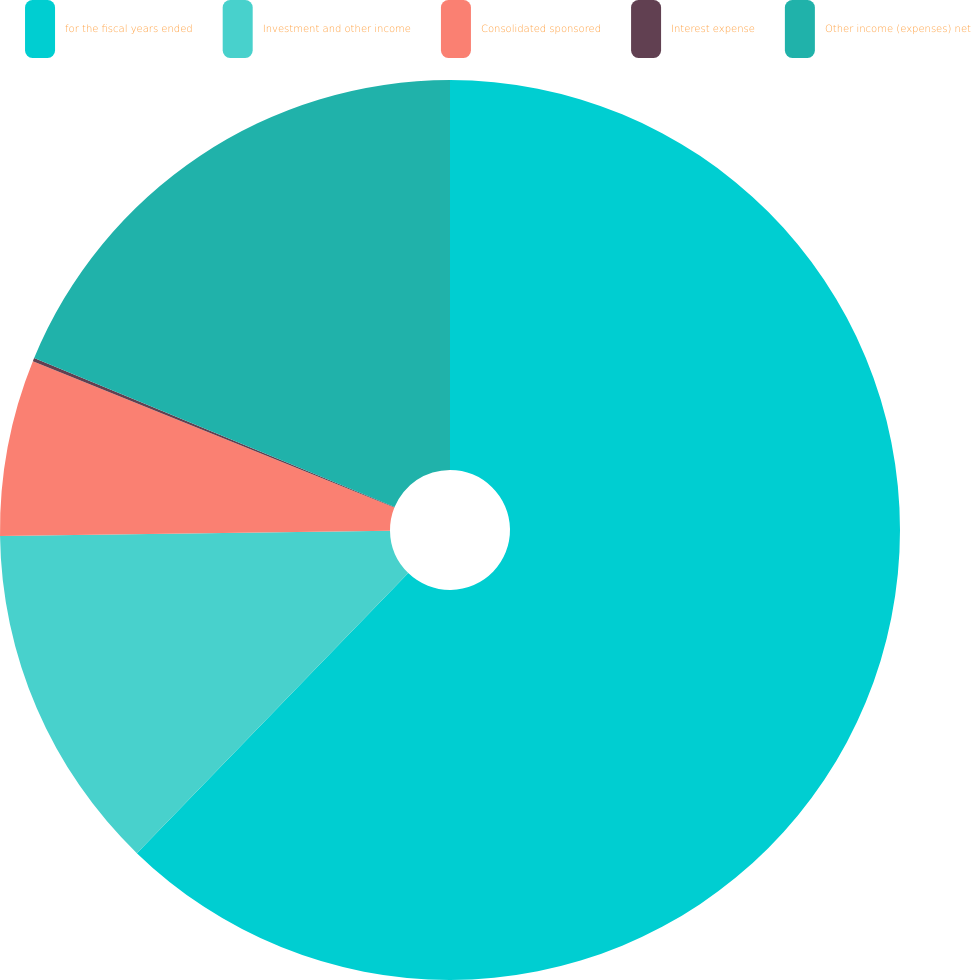<chart> <loc_0><loc_0><loc_500><loc_500><pie_chart><fcel>for the fiscal years ended<fcel>Investment and other income<fcel>Consolidated sponsored<fcel>Interest expense<fcel>Other income (expenses) net<nl><fcel>62.25%<fcel>12.54%<fcel>6.33%<fcel>0.12%<fcel>18.76%<nl></chart> 